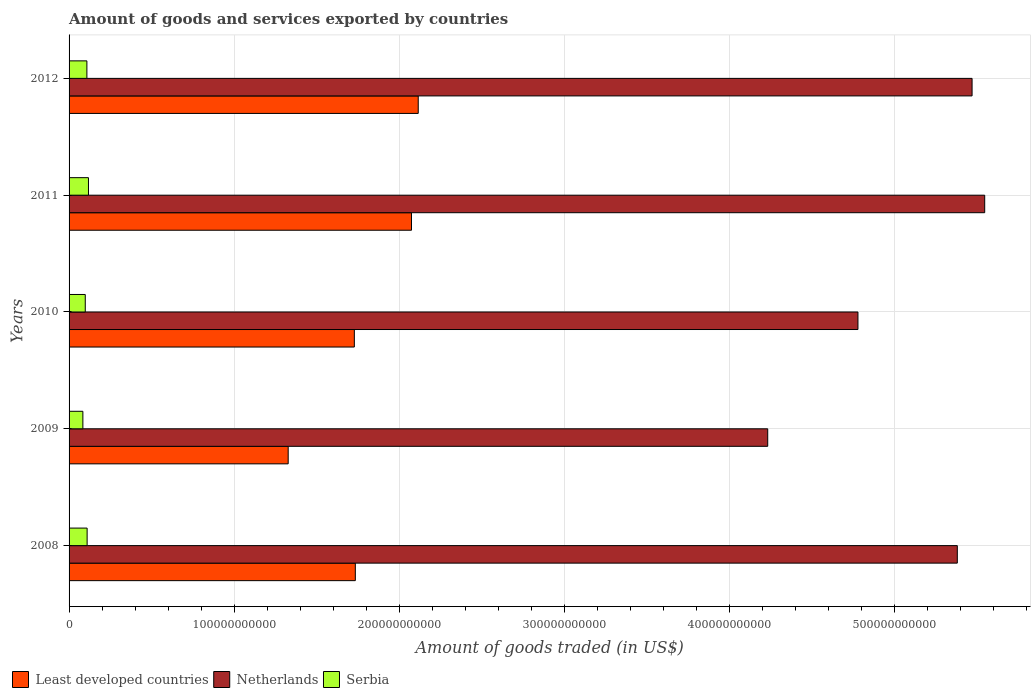How many different coloured bars are there?
Give a very brief answer. 3. In how many cases, is the number of bars for a given year not equal to the number of legend labels?
Provide a succinct answer. 0. What is the total amount of goods and services exported in Serbia in 2009?
Your answer should be very brief. 8.36e+09. Across all years, what is the maximum total amount of goods and services exported in Serbia?
Your response must be concise. 1.17e+1. Across all years, what is the minimum total amount of goods and services exported in Netherlands?
Provide a succinct answer. 4.23e+11. What is the total total amount of goods and services exported in Serbia in the graph?
Make the answer very short. 5.16e+1. What is the difference between the total amount of goods and services exported in Netherlands in 2008 and that in 2009?
Your answer should be very brief. 1.15e+11. What is the difference between the total amount of goods and services exported in Serbia in 2010 and the total amount of goods and services exported in Netherlands in 2012?
Give a very brief answer. -5.37e+11. What is the average total amount of goods and services exported in Serbia per year?
Provide a short and direct response. 1.03e+1. In the year 2009, what is the difference between the total amount of goods and services exported in Least developed countries and total amount of goods and services exported in Netherlands?
Provide a short and direct response. -2.90e+11. What is the ratio of the total amount of goods and services exported in Netherlands in 2008 to that in 2012?
Ensure brevity in your answer.  0.98. What is the difference between the highest and the second highest total amount of goods and services exported in Least developed countries?
Your answer should be very brief. 4.08e+09. What is the difference between the highest and the lowest total amount of goods and services exported in Netherlands?
Offer a terse response. 1.31e+11. What does the 2nd bar from the bottom in 2010 represents?
Keep it short and to the point. Netherlands. Are all the bars in the graph horizontal?
Offer a terse response. Yes. How many years are there in the graph?
Offer a very short reply. 5. What is the difference between two consecutive major ticks on the X-axis?
Give a very brief answer. 1.00e+11. Are the values on the major ticks of X-axis written in scientific E-notation?
Offer a terse response. No. Does the graph contain any zero values?
Offer a terse response. No. Where does the legend appear in the graph?
Ensure brevity in your answer.  Bottom left. How are the legend labels stacked?
Your response must be concise. Horizontal. What is the title of the graph?
Ensure brevity in your answer.  Amount of goods and services exported by countries. Does "Egypt, Arab Rep." appear as one of the legend labels in the graph?
Provide a short and direct response. No. What is the label or title of the X-axis?
Your answer should be compact. Amount of goods traded (in US$). What is the label or title of the Y-axis?
Your answer should be compact. Years. What is the Amount of goods traded (in US$) in Least developed countries in 2008?
Offer a very short reply. 1.73e+11. What is the Amount of goods traded (in US$) of Netherlands in 2008?
Keep it short and to the point. 5.38e+11. What is the Amount of goods traded (in US$) in Serbia in 2008?
Make the answer very short. 1.09e+1. What is the Amount of goods traded (in US$) in Least developed countries in 2009?
Make the answer very short. 1.33e+11. What is the Amount of goods traded (in US$) in Netherlands in 2009?
Your response must be concise. 4.23e+11. What is the Amount of goods traded (in US$) of Serbia in 2009?
Make the answer very short. 8.36e+09. What is the Amount of goods traded (in US$) in Least developed countries in 2010?
Your answer should be very brief. 1.73e+11. What is the Amount of goods traded (in US$) in Netherlands in 2010?
Make the answer very short. 4.78e+11. What is the Amount of goods traded (in US$) in Serbia in 2010?
Provide a short and direct response. 9.80e+09. What is the Amount of goods traded (in US$) in Least developed countries in 2011?
Offer a very short reply. 2.07e+11. What is the Amount of goods traded (in US$) in Netherlands in 2011?
Ensure brevity in your answer.  5.55e+11. What is the Amount of goods traded (in US$) in Serbia in 2011?
Provide a succinct answer. 1.17e+1. What is the Amount of goods traded (in US$) of Least developed countries in 2012?
Your answer should be compact. 2.11e+11. What is the Amount of goods traded (in US$) in Netherlands in 2012?
Offer a terse response. 5.47e+11. What is the Amount of goods traded (in US$) of Serbia in 2012?
Offer a terse response. 1.08e+1. Across all years, what is the maximum Amount of goods traded (in US$) in Least developed countries?
Provide a succinct answer. 2.11e+11. Across all years, what is the maximum Amount of goods traded (in US$) in Netherlands?
Make the answer very short. 5.55e+11. Across all years, what is the maximum Amount of goods traded (in US$) in Serbia?
Your response must be concise. 1.17e+1. Across all years, what is the minimum Amount of goods traded (in US$) in Least developed countries?
Offer a very short reply. 1.33e+11. Across all years, what is the minimum Amount of goods traded (in US$) of Netherlands?
Your answer should be very brief. 4.23e+11. Across all years, what is the minimum Amount of goods traded (in US$) of Serbia?
Keep it short and to the point. 8.36e+09. What is the total Amount of goods traded (in US$) in Least developed countries in the graph?
Offer a very short reply. 8.98e+11. What is the total Amount of goods traded (in US$) of Netherlands in the graph?
Your answer should be very brief. 2.54e+12. What is the total Amount of goods traded (in US$) of Serbia in the graph?
Your answer should be compact. 5.16e+1. What is the difference between the Amount of goods traded (in US$) in Least developed countries in 2008 and that in 2009?
Give a very brief answer. 4.07e+1. What is the difference between the Amount of goods traded (in US$) in Netherlands in 2008 and that in 2009?
Give a very brief answer. 1.15e+11. What is the difference between the Amount of goods traded (in US$) of Serbia in 2008 and that in 2009?
Make the answer very short. 2.58e+09. What is the difference between the Amount of goods traded (in US$) of Least developed countries in 2008 and that in 2010?
Your answer should be very brief. 6.04e+08. What is the difference between the Amount of goods traded (in US$) in Netherlands in 2008 and that in 2010?
Offer a very short reply. 6.02e+1. What is the difference between the Amount of goods traded (in US$) in Serbia in 2008 and that in 2010?
Offer a very short reply. 1.13e+09. What is the difference between the Amount of goods traded (in US$) in Least developed countries in 2008 and that in 2011?
Give a very brief answer. -3.40e+1. What is the difference between the Amount of goods traded (in US$) in Netherlands in 2008 and that in 2011?
Make the answer very short. -1.66e+1. What is the difference between the Amount of goods traded (in US$) in Serbia in 2008 and that in 2011?
Provide a succinct answer. -8.10e+08. What is the difference between the Amount of goods traded (in US$) of Least developed countries in 2008 and that in 2012?
Make the answer very short. -3.81e+1. What is the difference between the Amount of goods traded (in US$) of Netherlands in 2008 and that in 2012?
Keep it short and to the point. -8.94e+09. What is the difference between the Amount of goods traded (in US$) of Serbia in 2008 and that in 2012?
Your answer should be compact. 1.45e+08. What is the difference between the Amount of goods traded (in US$) of Least developed countries in 2009 and that in 2010?
Ensure brevity in your answer.  -4.01e+1. What is the difference between the Amount of goods traded (in US$) of Netherlands in 2009 and that in 2010?
Offer a terse response. -5.46e+1. What is the difference between the Amount of goods traded (in US$) of Serbia in 2009 and that in 2010?
Offer a terse response. -1.44e+09. What is the difference between the Amount of goods traded (in US$) of Least developed countries in 2009 and that in 2011?
Keep it short and to the point. -7.47e+1. What is the difference between the Amount of goods traded (in US$) of Netherlands in 2009 and that in 2011?
Your response must be concise. -1.31e+11. What is the difference between the Amount of goods traded (in US$) of Serbia in 2009 and that in 2011?
Provide a short and direct response. -3.39e+09. What is the difference between the Amount of goods traded (in US$) in Least developed countries in 2009 and that in 2012?
Make the answer very short. -7.88e+1. What is the difference between the Amount of goods traded (in US$) in Netherlands in 2009 and that in 2012?
Your answer should be compact. -1.24e+11. What is the difference between the Amount of goods traded (in US$) in Serbia in 2009 and that in 2012?
Provide a succinct answer. -2.43e+09. What is the difference between the Amount of goods traded (in US$) of Least developed countries in 2010 and that in 2011?
Ensure brevity in your answer.  -3.46e+1. What is the difference between the Amount of goods traded (in US$) of Netherlands in 2010 and that in 2011?
Provide a short and direct response. -7.68e+1. What is the difference between the Amount of goods traded (in US$) of Serbia in 2010 and that in 2011?
Your answer should be very brief. -1.94e+09. What is the difference between the Amount of goods traded (in US$) of Least developed countries in 2010 and that in 2012?
Make the answer very short. -3.87e+1. What is the difference between the Amount of goods traded (in US$) in Netherlands in 2010 and that in 2012?
Make the answer very short. -6.91e+1. What is the difference between the Amount of goods traded (in US$) in Serbia in 2010 and that in 2012?
Ensure brevity in your answer.  -9.89e+08. What is the difference between the Amount of goods traded (in US$) in Least developed countries in 2011 and that in 2012?
Your answer should be very brief. -4.08e+09. What is the difference between the Amount of goods traded (in US$) of Netherlands in 2011 and that in 2012?
Keep it short and to the point. 7.65e+09. What is the difference between the Amount of goods traded (in US$) in Serbia in 2011 and that in 2012?
Offer a very short reply. 9.55e+08. What is the difference between the Amount of goods traded (in US$) of Least developed countries in 2008 and the Amount of goods traded (in US$) of Netherlands in 2009?
Ensure brevity in your answer.  -2.50e+11. What is the difference between the Amount of goods traded (in US$) in Least developed countries in 2008 and the Amount of goods traded (in US$) in Serbia in 2009?
Ensure brevity in your answer.  1.65e+11. What is the difference between the Amount of goods traded (in US$) of Netherlands in 2008 and the Amount of goods traded (in US$) of Serbia in 2009?
Keep it short and to the point. 5.30e+11. What is the difference between the Amount of goods traded (in US$) in Least developed countries in 2008 and the Amount of goods traded (in US$) in Netherlands in 2010?
Give a very brief answer. -3.04e+11. What is the difference between the Amount of goods traded (in US$) of Least developed countries in 2008 and the Amount of goods traded (in US$) of Serbia in 2010?
Your response must be concise. 1.64e+11. What is the difference between the Amount of goods traded (in US$) of Netherlands in 2008 and the Amount of goods traded (in US$) of Serbia in 2010?
Ensure brevity in your answer.  5.28e+11. What is the difference between the Amount of goods traded (in US$) in Least developed countries in 2008 and the Amount of goods traded (in US$) in Netherlands in 2011?
Provide a succinct answer. -3.81e+11. What is the difference between the Amount of goods traded (in US$) of Least developed countries in 2008 and the Amount of goods traded (in US$) of Serbia in 2011?
Ensure brevity in your answer.  1.62e+11. What is the difference between the Amount of goods traded (in US$) in Netherlands in 2008 and the Amount of goods traded (in US$) in Serbia in 2011?
Provide a succinct answer. 5.26e+11. What is the difference between the Amount of goods traded (in US$) of Least developed countries in 2008 and the Amount of goods traded (in US$) of Netherlands in 2012?
Offer a terse response. -3.74e+11. What is the difference between the Amount of goods traded (in US$) in Least developed countries in 2008 and the Amount of goods traded (in US$) in Serbia in 2012?
Make the answer very short. 1.63e+11. What is the difference between the Amount of goods traded (in US$) of Netherlands in 2008 and the Amount of goods traded (in US$) of Serbia in 2012?
Offer a very short reply. 5.27e+11. What is the difference between the Amount of goods traded (in US$) in Least developed countries in 2009 and the Amount of goods traded (in US$) in Netherlands in 2010?
Keep it short and to the point. -3.45e+11. What is the difference between the Amount of goods traded (in US$) of Least developed countries in 2009 and the Amount of goods traded (in US$) of Serbia in 2010?
Offer a terse response. 1.23e+11. What is the difference between the Amount of goods traded (in US$) of Netherlands in 2009 and the Amount of goods traded (in US$) of Serbia in 2010?
Provide a short and direct response. 4.13e+11. What is the difference between the Amount of goods traded (in US$) in Least developed countries in 2009 and the Amount of goods traded (in US$) in Netherlands in 2011?
Your answer should be very brief. -4.22e+11. What is the difference between the Amount of goods traded (in US$) of Least developed countries in 2009 and the Amount of goods traded (in US$) of Serbia in 2011?
Provide a succinct answer. 1.21e+11. What is the difference between the Amount of goods traded (in US$) of Netherlands in 2009 and the Amount of goods traded (in US$) of Serbia in 2011?
Keep it short and to the point. 4.11e+11. What is the difference between the Amount of goods traded (in US$) of Least developed countries in 2009 and the Amount of goods traded (in US$) of Netherlands in 2012?
Offer a very short reply. -4.14e+11. What is the difference between the Amount of goods traded (in US$) of Least developed countries in 2009 and the Amount of goods traded (in US$) of Serbia in 2012?
Ensure brevity in your answer.  1.22e+11. What is the difference between the Amount of goods traded (in US$) in Netherlands in 2009 and the Amount of goods traded (in US$) in Serbia in 2012?
Keep it short and to the point. 4.12e+11. What is the difference between the Amount of goods traded (in US$) of Least developed countries in 2010 and the Amount of goods traded (in US$) of Netherlands in 2011?
Make the answer very short. -3.82e+11. What is the difference between the Amount of goods traded (in US$) in Least developed countries in 2010 and the Amount of goods traded (in US$) in Serbia in 2011?
Ensure brevity in your answer.  1.61e+11. What is the difference between the Amount of goods traded (in US$) in Netherlands in 2010 and the Amount of goods traded (in US$) in Serbia in 2011?
Your answer should be compact. 4.66e+11. What is the difference between the Amount of goods traded (in US$) in Least developed countries in 2010 and the Amount of goods traded (in US$) in Netherlands in 2012?
Keep it short and to the point. -3.74e+11. What is the difference between the Amount of goods traded (in US$) in Least developed countries in 2010 and the Amount of goods traded (in US$) in Serbia in 2012?
Your answer should be compact. 1.62e+11. What is the difference between the Amount of goods traded (in US$) of Netherlands in 2010 and the Amount of goods traded (in US$) of Serbia in 2012?
Ensure brevity in your answer.  4.67e+11. What is the difference between the Amount of goods traded (in US$) in Least developed countries in 2011 and the Amount of goods traded (in US$) in Netherlands in 2012?
Provide a short and direct response. -3.40e+11. What is the difference between the Amount of goods traded (in US$) of Least developed countries in 2011 and the Amount of goods traded (in US$) of Serbia in 2012?
Make the answer very short. 1.97e+11. What is the difference between the Amount of goods traded (in US$) in Netherlands in 2011 and the Amount of goods traded (in US$) in Serbia in 2012?
Your answer should be very brief. 5.44e+11. What is the average Amount of goods traded (in US$) of Least developed countries per year?
Keep it short and to the point. 1.80e+11. What is the average Amount of goods traded (in US$) in Netherlands per year?
Offer a very short reply. 5.08e+11. What is the average Amount of goods traded (in US$) of Serbia per year?
Ensure brevity in your answer.  1.03e+1. In the year 2008, what is the difference between the Amount of goods traded (in US$) of Least developed countries and Amount of goods traded (in US$) of Netherlands?
Provide a short and direct response. -3.65e+11. In the year 2008, what is the difference between the Amount of goods traded (in US$) of Least developed countries and Amount of goods traded (in US$) of Serbia?
Keep it short and to the point. 1.62e+11. In the year 2008, what is the difference between the Amount of goods traded (in US$) in Netherlands and Amount of goods traded (in US$) in Serbia?
Make the answer very short. 5.27e+11. In the year 2009, what is the difference between the Amount of goods traded (in US$) of Least developed countries and Amount of goods traded (in US$) of Netherlands?
Offer a very short reply. -2.90e+11. In the year 2009, what is the difference between the Amount of goods traded (in US$) of Least developed countries and Amount of goods traded (in US$) of Serbia?
Your response must be concise. 1.24e+11. In the year 2009, what is the difference between the Amount of goods traded (in US$) in Netherlands and Amount of goods traded (in US$) in Serbia?
Make the answer very short. 4.15e+11. In the year 2010, what is the difference between the Amount of goods traded (in US$) in Least developed countries and Amount of goods traded (in US$) in Netherlands?
Your answer should be compact. -3.05e+11. In the year 2010, what is the difference between the Amount of goods traded (in US$) in Least developed countries and Amount of goods traded (in US$) in Serbia?
Provide a succinct answer. 1.63e+11. In the year 2010, what is the difference between the Amount of goods traded (in US$) in Netherlands and Amount of goods traded (in US$) in Serbia?
Provide a short and direct response. 4.68e+11. In the year 2011, what is the difference between the Amount of goods traded (in US$) in Least developed countries and Amount of goods traded (in US$) in Netherlands?
Your response must be concise. -3.47e+11. In the year 2011, what is the difference between the Amount of goods traded (in US$) of Least developed countries and Amount of goods traded (in US$) of Serbia?
Provide a succinct answer. 1.96e+11. In the year 2011, what is the difference between the Amount of goods traded (in US$) of Netherlands and Amount of goods traded (in US$) of Serbia?
Keep it short and to the point. 5.43e+11. In the year 2012, what is the difference between the Amount of goods traded (in US$) of Least developed countries and Amount of goods traded (in US$) of Netherlands?
Ensure brevity in your answer.  -3.35e+11. In the year 2012, what is the difference between the Amount of goods traded (in US$) of Least developed countries and Amount of goods traded (in US$) of Serbia?
Keep it short and to the point. 2.01e+11. In the year 2012, what is the difference between the Amount of goods traded (in US$) in Netherlands and Amount of goods traded (in US$) in Serbia?
Offer a terse response. 5.36e+11. What is the ratio of the Amount of goods traded (in US$) of Least developed countries in 2008 to that in 2009?
Make the answer very short. 1.31. What is the ratio of the Amount of goods traded (in US$) of Netherlands in 2008 to that in 2009?
Your response must be concise. 1.27. What is the ratio of the Amount of goods traded (in US$) of Serbia in 2008 to that in 2009?
Your response must be concise. 1.31. What is the ratio of the Amount of goods traded (in US$) in Least developed countries in 2008 to that in 2010?
Your response must be concise. 1. What is the ratio of the Amount of goods traded (in US$) in Netherlands in 2008 to that in 2010?
Give a very brief answer. 1.13. What is the ratio of the Amount of goods traded (in US$) in Serbia in 2008 to that in 2010?
Make the answer very short. 1.12. What is the ratio of the Amount of goods traded (in US$) of Least developed countries in 2008 to that in 2011?
Make the answer very short. 0.84. What is the ratio of the Amount of goods traded (in US$) of Netherlands in 2008 to that in 2011?
Make the answer very short. 0.97. What is the ratio of the Amount of goods traded (in US$) of Serbia in 2008 to that in 2011?
Provide a short and direct response. 0.93. What is the ratio of the Amount of goods traded (in US$) in Least developed countries in 2008 to that in 2012?
Your answer should be compact. 0.82. What is the ratio of the Amount of goods traded (in US$) of Netherlands in 2008 to that in 2012?
Your answer should be compact. 0.98. What is the ratio of the Amount of goods traded (in US$) in Serbia in 2008 to that in 2012?
Your answer should be compact. 1.01. What is the ratio of the Amount of goods traded (in US$) in Least developed countries in 2009 to that in 2010?
Offer a very short reply. 0.77. What is the ratio of the Amount of goods traded (in US$) in Netherlands in 2009 to that in 2010?
Provide a short and direct response. 0.89. What is the ratio of the Amount of goods traded (in US$) in Serbia in 2009 to that in 2010?
Make the answer very short. 0.85. What is the ratio of the Amount of goods traded (in US$) of Least developed countries in 2009 to that in 2011?
Offer a very short reply. 0.64. What is the ratio of the Amount of goods traded (in US$) of Netherlands in 2009 to that in 2011?
Ensure brevity in your answer.  0.76. What is the ratio of the Amount of goods traded (in US$) of Serbia in 2009 to that in 2011?
Offer a terse response. 0.71. What is the ratio of the Amount of goods traded (in US$) in Least developed countries in 2009 to that in 2012?
Your answer should be very brief. 0.63. What is the ratio of the Amount of goods traded (in US$) of Netherlands in 2009 to that in 2012?
Offer a very short reply. 0.77. What is the ratio of the Amount of goods traded (in US$) of Serbia in 2009 to that in 2012?
Keep it short and to the point. 0.77. What is the ratio of the Amount of goods traded (in US$) in Least developed countries in 2010 to that in 2011?
Provide a succinct answer. 0.83. What is the ratio of the Amount of goods traded (in US$) in Netherlands in 2010 to that in 2011?
Provide a short and direct response. 0.86. What is the ratio of the Amount of goods traded (in US$) in Serbia in 2010 to that in 2011?
Offer a very short reply. 0.83. What is the ratio of the Amount of goods traded (in US$) of Least developed countries in 2010 to that in 2012?
Provide a succinct answer. 0.82. What is the ratio of the Amount of goods traded (in US$) of Netherlands in 2010 to that in 2012?
Give a very brief answer. 0.87. What is the ratio of the Amount of goods traded (in US$) in Serbia in 2010 to that in 2012?
Provide a succinct answer. 0.91. What is the ratio of the Amount of goods traded (in US$) of Least developed countries in 2011 to that in 2012?
Your response must be concise. 0.98. What is the ratio of the Amount of goods traded (in US$) in Netherlands in 2011 to that in 2012?
Your answer should be very brief. 1.01. What is the ratio of the Amount of goods traded (in US$) of Serbia in 2011 to that in 2012?
Provide a short and direct response. 1.09. What is the difference between the highest and the second highest Amount of goods traded (in US$) in Least developed countries?
Your answer should be compact. 4.08e+09. What is the difference between the highest and the second highest Amount of goods traded (in US$) of Netherlands?
Your response must be concise. 7.65e+09. What is the difference between the highest and the second highest Amount of goods traded (in US$) in Serbia?
Keep it short and to the point. 8.10e+08. What is the difference between the highest and the lowest Amount of goods traded (in US$) of Least developed countries?
Your answer should be very brief. 7.88e+1. What is the difference between the highest and the lowest Amount of goods traded (in US$) in Netherlands?
Your response must be concise. 1.31e+11. What is the difference between the highest and the lowest Amount of goods traded (in US$) of Serbia?
Make the answer very short. 3.39e+09. 